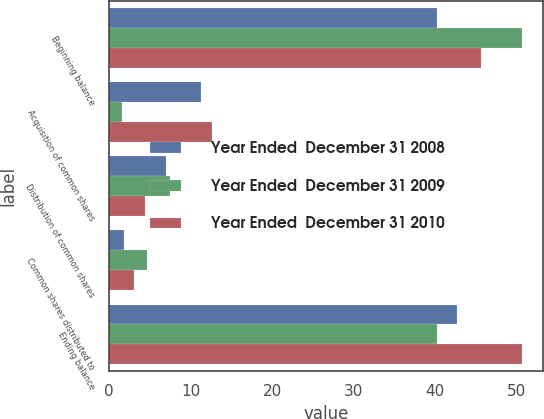Convert chart to OTSL. <chart><loc_0><loc_0><loc_500><loc_500><stacked_bar_chart><ecel><fcel>Beginning balance<fcel>Acquisition of common shares<fcel>Distribution of common shares<fcel>Common shares distributed to<fcel>Ending balance<nl><fcel>Year Ended  December 31 2008<fcel>40.2<fcel>11.3<fcel>7<fcel>1.8<fcel>42.7<nl><fcel>Year Ended  December 31 2009<fcel>50.7<fcel>1.6<fcel>7.5<fcel>4.6<fcel>40.2<nl><fcel>Year Ended  December 31 2010<fcel>45.6<fcel>12.6<fcel>4.4<fcel>3.1<fcel>50.7<nl></chart> 